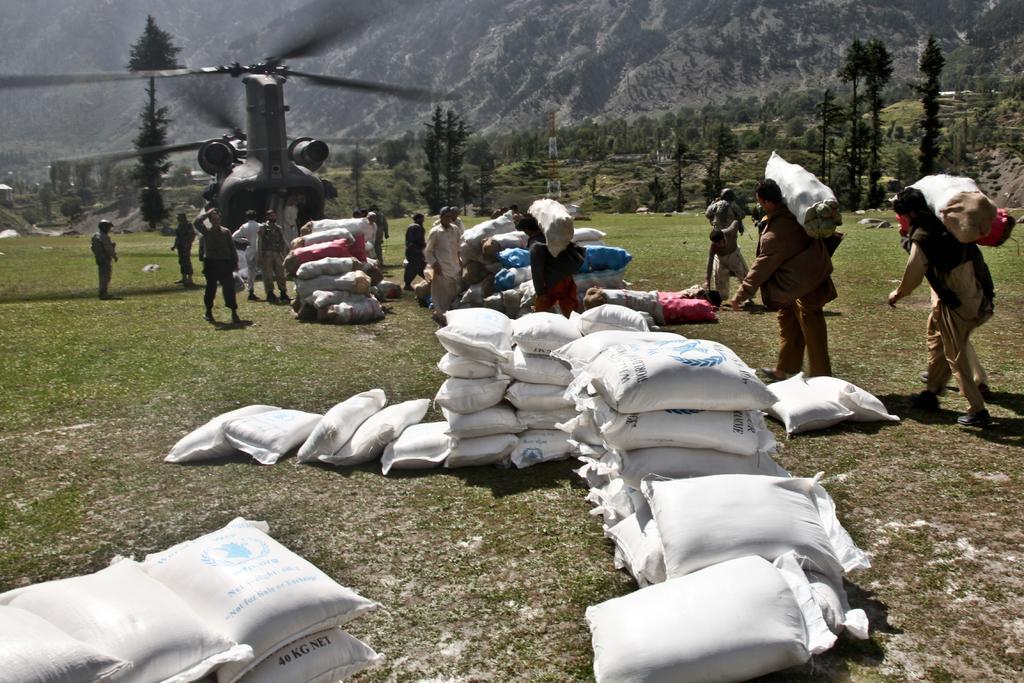Describe this image in one or two sentences. There are sacks in the foreground area of the image, there are people carrying sacks, an aircraft, trees and mountains in the background. 